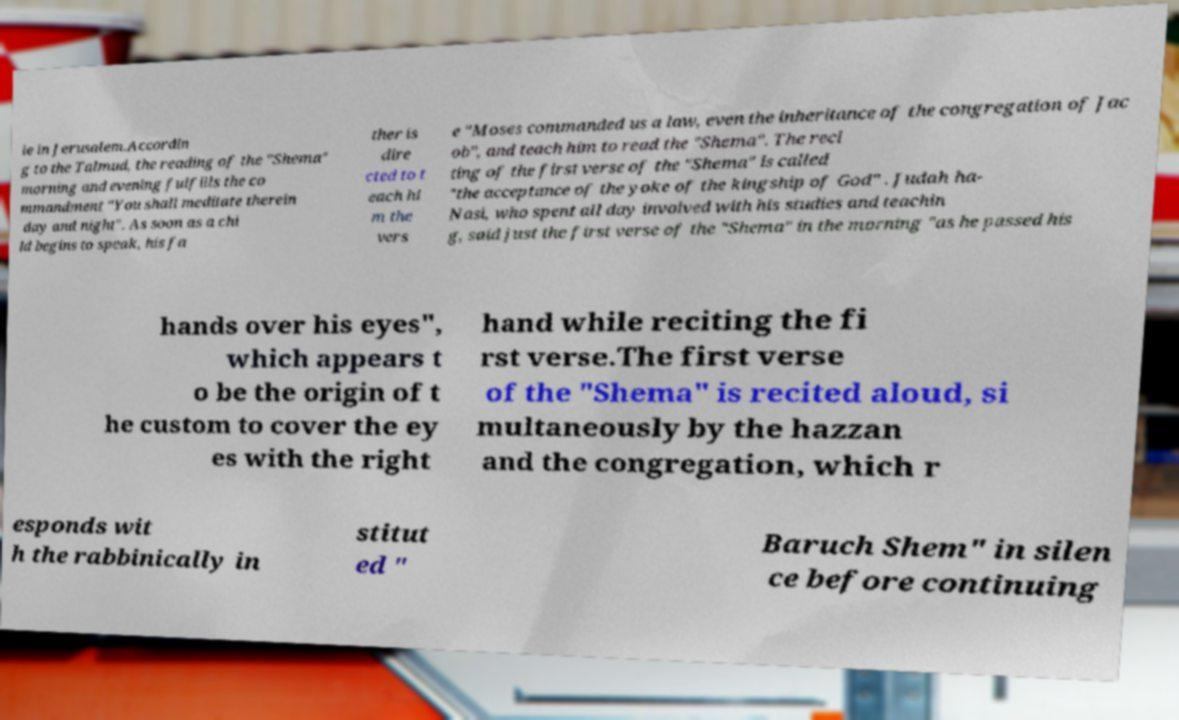Could you assist in decoding the text presented in this image and type it out clearly? le in Jerusalem.Accordin g to the Talmud, the reading of the "Shema" morning and evening fulfills the co mmandment "You shall meditate therein day and night". As soon as a chi ld begins to speak, his fa ther is dire cted to t each hi m the vers e "Moses commanded us a law, even the inheritance of the congregation of Jac ob", and teach him to read the "Shema". The reci ting of the first verse of the "Shema" is called "the acceptance of the yoke of the kingship of God" . Judah ha- Nasi, who spent all day involved with his studies and teachin g, said just the first verse of the "Shema" in the morning "as he passed his hands over his eyes", which appears t o be the origin of t he custom to cover the ey es with the right hand while reciting the fi rst verse.The first verse of the "Shema" is recited aloud, si multaneously by the hazzan and the congregation, which r esponds wit h the rabbinically in stitut ed " Baruch Shem" in silen ce before continuing 